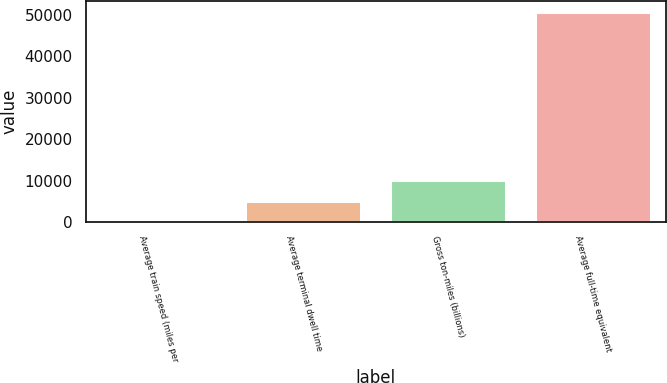Convert chart to OTSL. <chart><loc_0><loc_0><loc_500><loc_500><bar_chart><fcel>Average train speed (miles per<fcel>Average terminal dwell time<fcel>Gross ton-miles (billions)<fcel>Average full-time equivalent<nl><fcel>21.4<fcel>5093.16<fcel>10164.9<fcel>50739<nl></chart> 